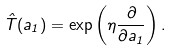Convert formula to latex. <formula><loc_0><loc_0><loc_500><loc_500>\hat { T } ( a _ { 1 } ) = \exp \left ( \eta \frac { \partial } { \partial a _ { 1 } } \right ) .</formula> 